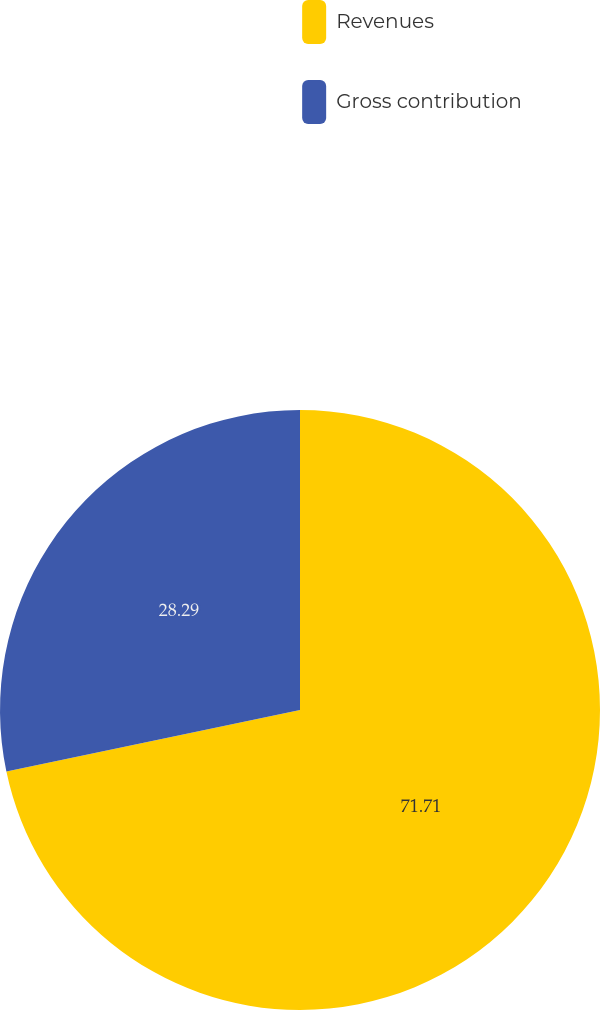<chart> <loc_0><loc_0><loc_500><loc_500><pie_chart><fcel>Revenues<fcel>Gross contribution<nl><fcel>71.71%<fcel>28.29%<nl></chart> 